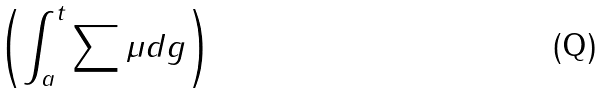<formula> <loc_0><loc_0><loc_500><loc_500>\left ( \int _ { a } ^ { t } \sum { \mu } d g \right )</formula> 